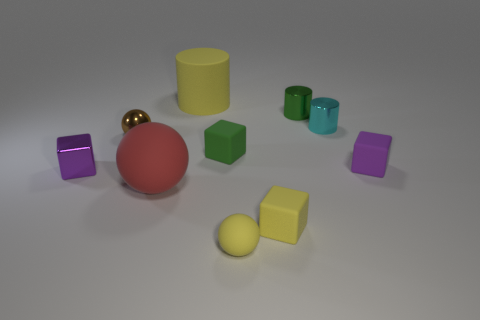There is a purple metallic thing that is the same size as the cyan metallic object; what is its shape? cube 